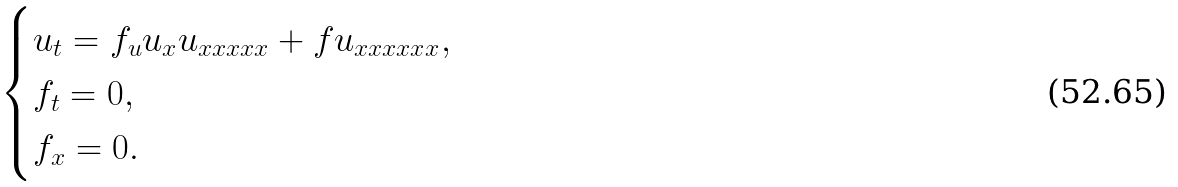<formula> <loc_0><loc_0><loc_500><loc_500>\begin{cases} u _ { t } = f _ { u } u _ { x } u _ { x x x x x } + f u _ { x x x x x x } , \\ f _ { t } = 0 , \\ f _ { x } = 0 . \end{cases}</formula> 